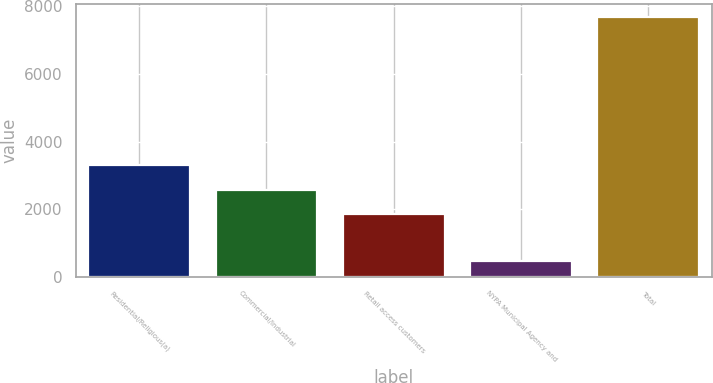<chart> <loc_0><loc_0><loc_500><loc_500><bar_chart><fcel>Residential/Religious(a)<fcel>Commercial/Industrial<fcel>Retail access customers<fcel>NYPA Municipal Agency and<fcel>Total<nl><fcel>3298.4<fcel>2576.7<fcel>1855<fcel>457<fcel>7674<nl></chart> 